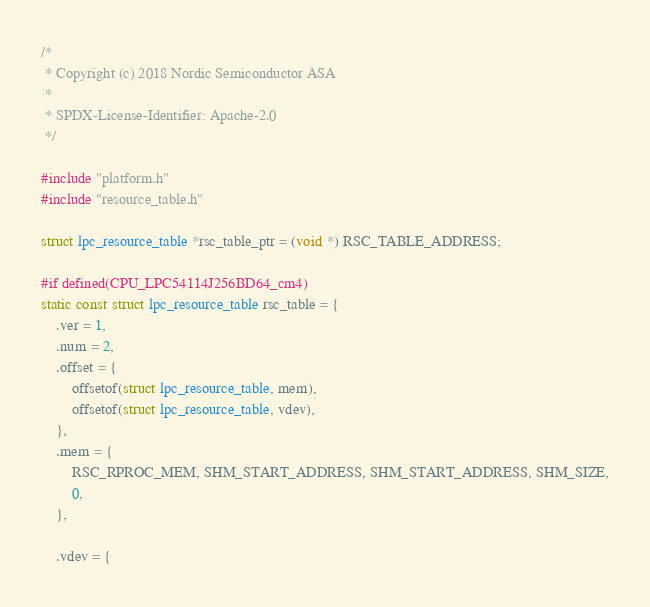<code> <loc_0><loc_0><loc_500><loc_500><_C_>/*
 * Copyright (c) 2018 Nordic Semiconductor ASA
 *
 * SPDX-License-Identifier: Apache-2.0
 */

#include "platform.h"
#include "resource_table.h"

struct lpc_resource_table *rsc_table_ptr = (void *) RSC_TABLE_ADDRESS;

#if defined(CPU_LPC54114J256BD64_cm4)
static const struct lpc_resource_table rsc_table = {
	.ver = 1,
	.num = 2,
	.offset = {
		offsetof(struct lpc_resource_table, mem),
		offsetof(struct lpc_resource_table, vdev),
	},
	.mem = {
		RSC_RPROC_MEM, SHM_START_ADDRESS, SHM_START_ADDRESS, SHM_SIZE,
		0,
	},

	.vdev = {</code> 